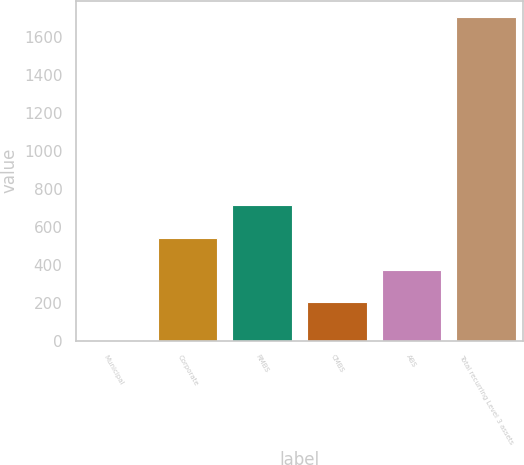<chart> <loc_0><loc_0><loc_500><loc_500><bar_chart><fcel>Municipal<fcel>Corporate<fcel>RMBS<fcel>CMBS<fcel>ABS<fcel>Total recurring Level 3 assets<nl><fcel>5<fcel>542.2<fcel>712.3<fcel>202<fcel>372.1<fcel>1706<nl></chart> 